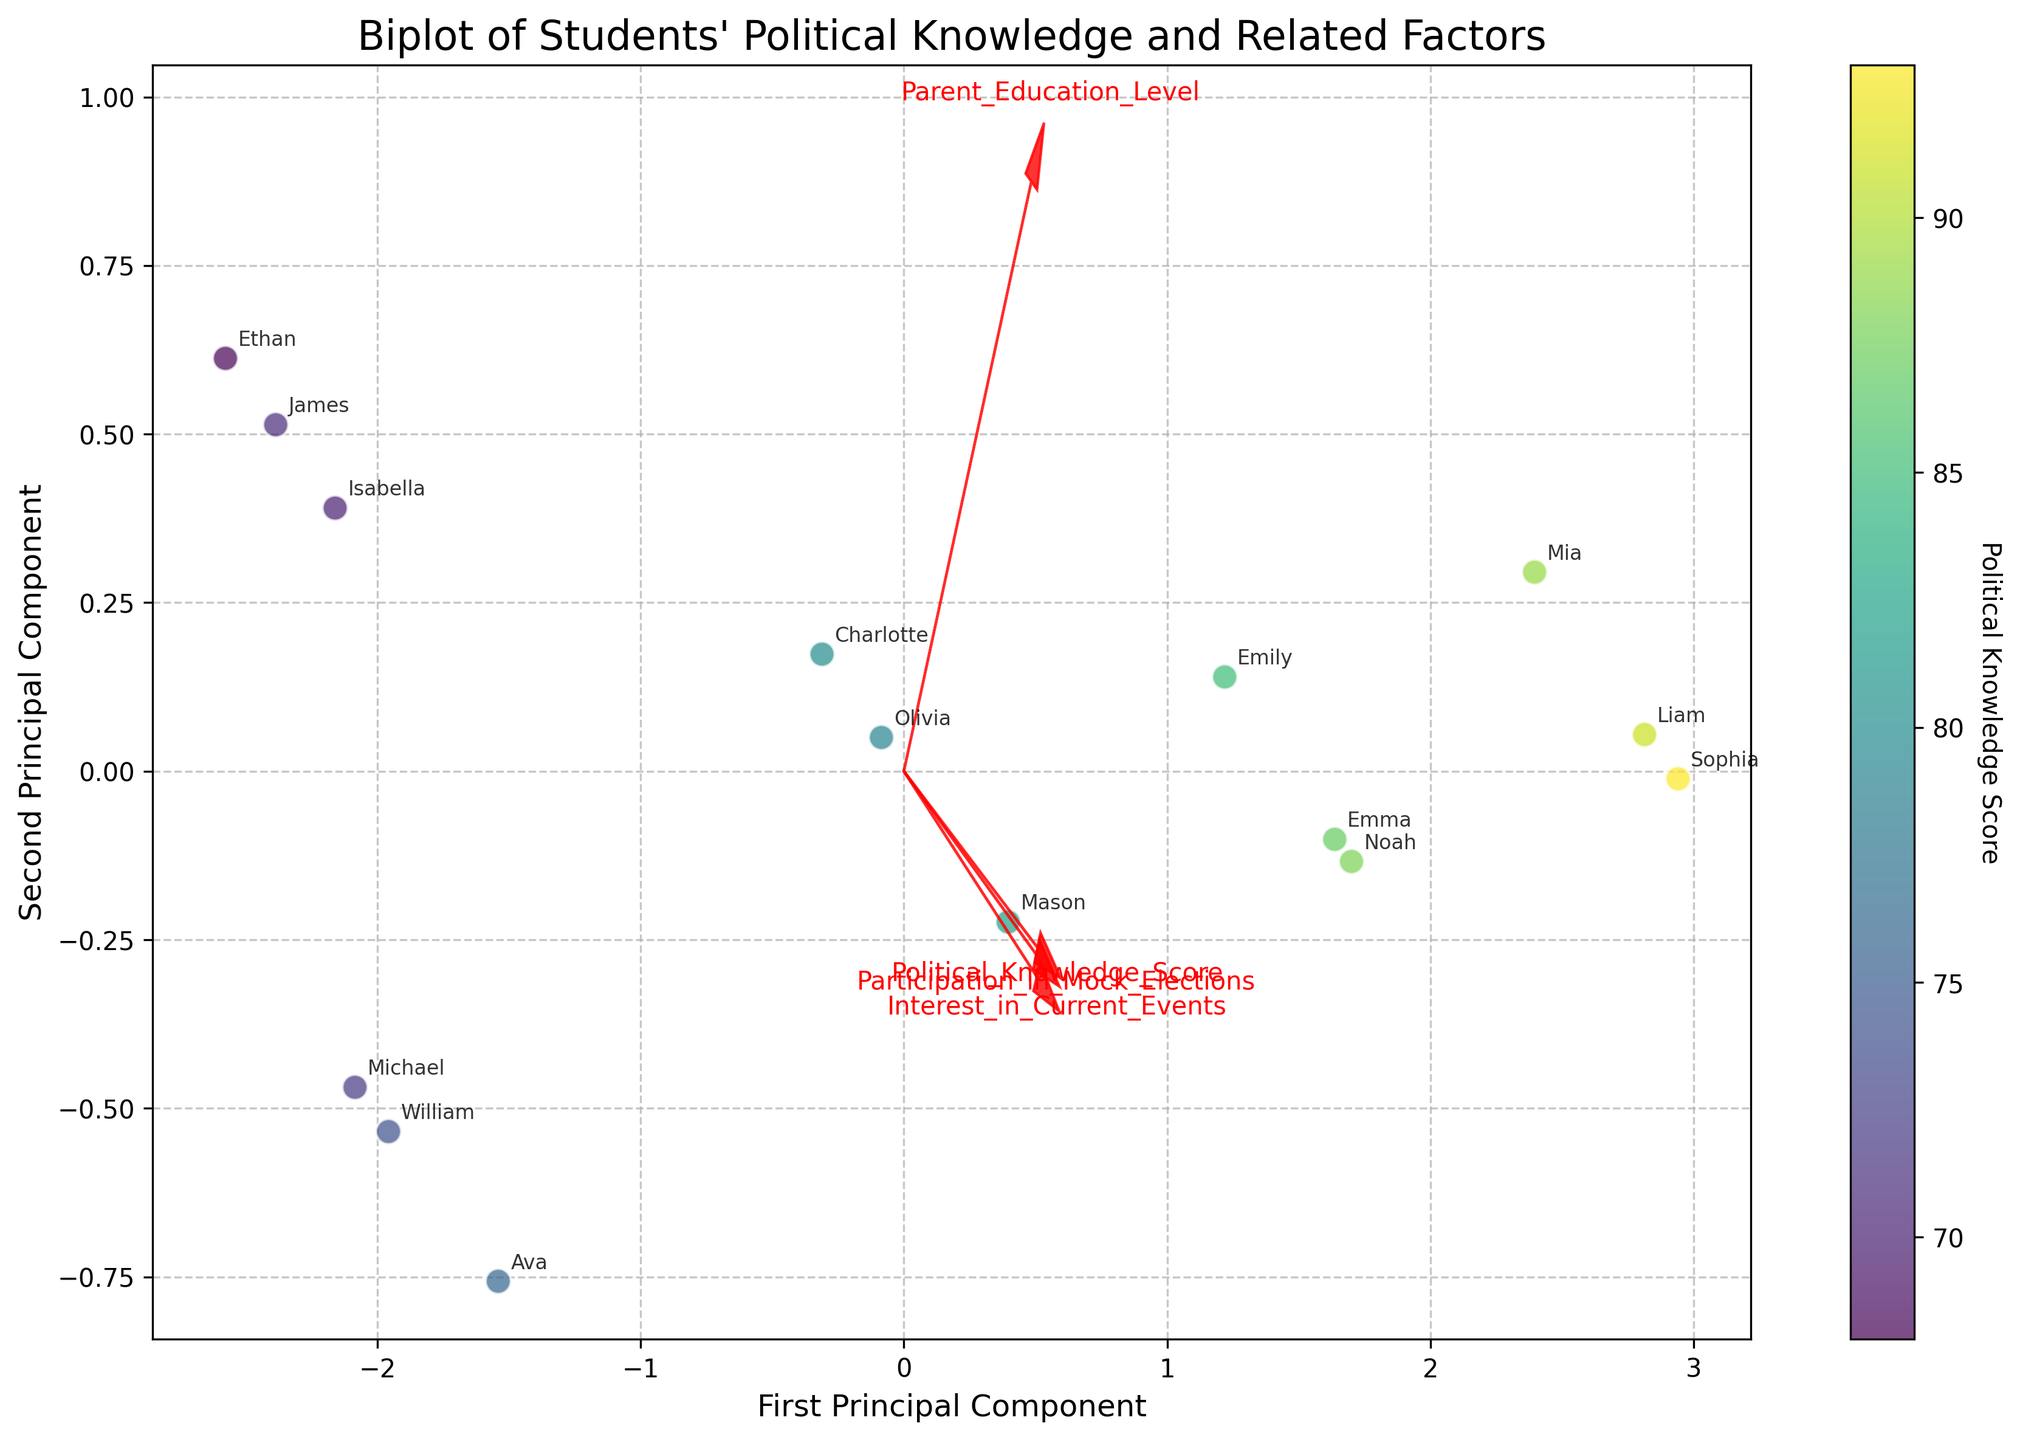Which axis represents the first principal component? The first principal component is labeled on the x-axis. It’s indicated by the label "First Principal Component" on the plot.
Answer: x-axis What is the title of the figure? The title of the figure is located at the top of the plot and reads "Biplot of Students' Political Knowledge and Related Factors."
Answer: Biplot of Students' Political Knowledge and Related Factors How are the students’ Political Knowledge Scores visually represented? The students' Political Knowledge Scores are represented by the colors of the data points, with their intensity displayed on the color bar labeled "Political Knowledge Score" on the right side of the plot.
Answer: By colors Which data point has the highest Political Knowledge Score? The data point with the highest score is likely one of the darkest in color (indicating higher values on the color bar). Inspecting the labels, "Sophia" and "Liam" are two candidates with high scores and almost identical positions.
Answer: Sophia or Liam Where is the “Parent Education Level” feature vector pointing? The feature vector for "Parent Education Level" is represented by a red arrow, and it points towards the top-right quadrant of the plot, indicating a positive correlation with both principal components.
Answer: Top-right Which feature appears to have the weakest association with the first principal component? By looking at the lengths and directions of the arrows, "Interest in Current Events" has a relatively small projection on the first principal component axis compared to the others, indicating a weaker association.
Answer: Interest in Current Events How many students have a “Graduate” parent education level? We can determine this by analyzing the positions of students near the direction of the "Parent Education Level" vector (with an appropriate score). The students with a "Graduate" level must be cross-checked with the annotations: "Emily," "Noah," and "Emma" have this parent education level.
Answer: 3 Which student most closely aligns with the “Bachelor's” parent education level while also scoring high in political knowledge? Look for a student positioned towards the "Bachelor's" vector with a relatively dark color (higher knowledge score). "Mason" fits this criterion well.
Answer: Mason Which two features show the most positive correlation with each other? The feature vectors' directions indicate their correlation. "Interest in Current Events" and "Participation in Mock Elections" vectors both point in similar directions, suggesting a strong positive correlation.
Answer: Interest in Current Events and Participation in Mock Elections Which student demonstrates a high interest in current events but a relatively lower Political Knowledge Score? Find a student positioned in the direction of the "Interest in Current Events" vector but has a lighter color indicating lower knowledge. "Michael" fits this description.
Answer: Michael 